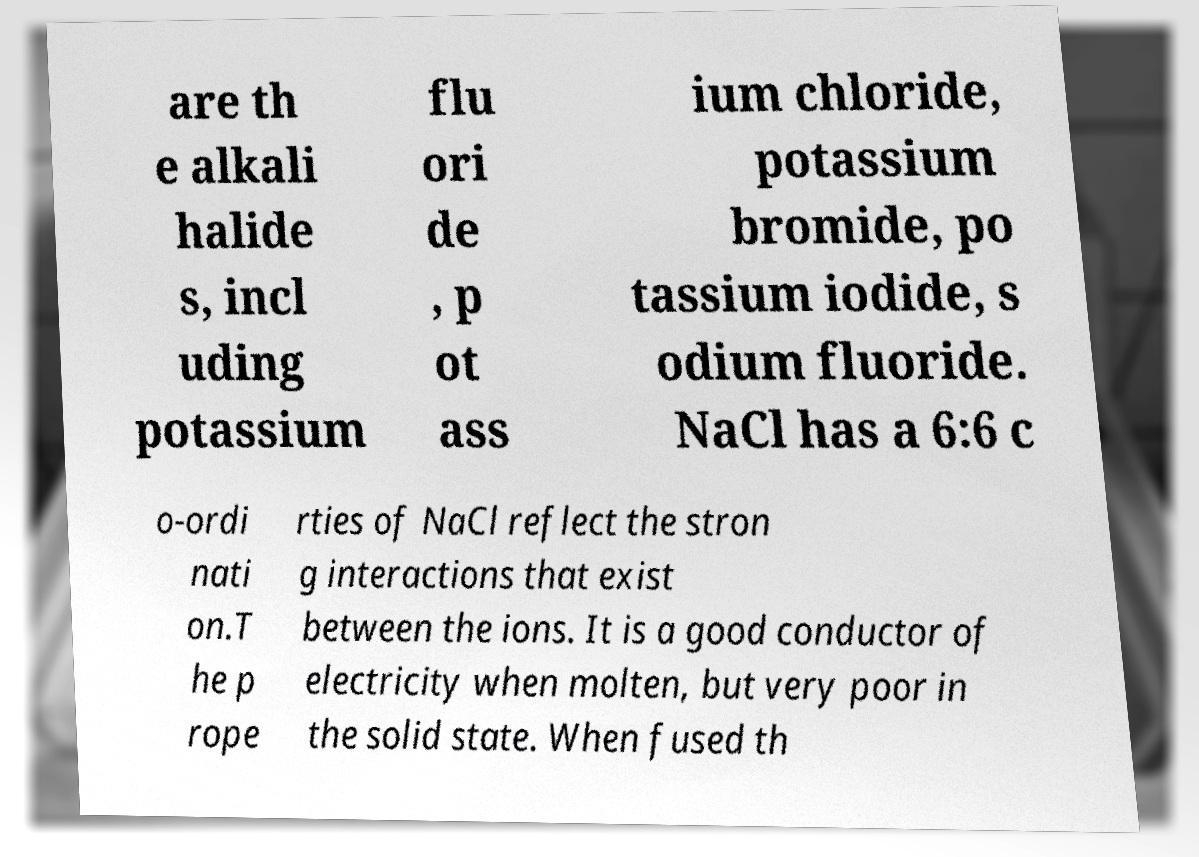For documentation purposes, I need the text within this image transcribed. Could you provide that? are th e alkali halide s, incl uding potassium flu ori de , p ot ass ium chloride, potassium bromide, po tassium iodide, s odium fluoride. NaCl has a 6:6 c o-ordi nati on.T he p rope rties of NaCl reflect the stron g interactions that exist between the ions. It is a good conductor of electricity when molten, but very poor in the solid state. When fused th 